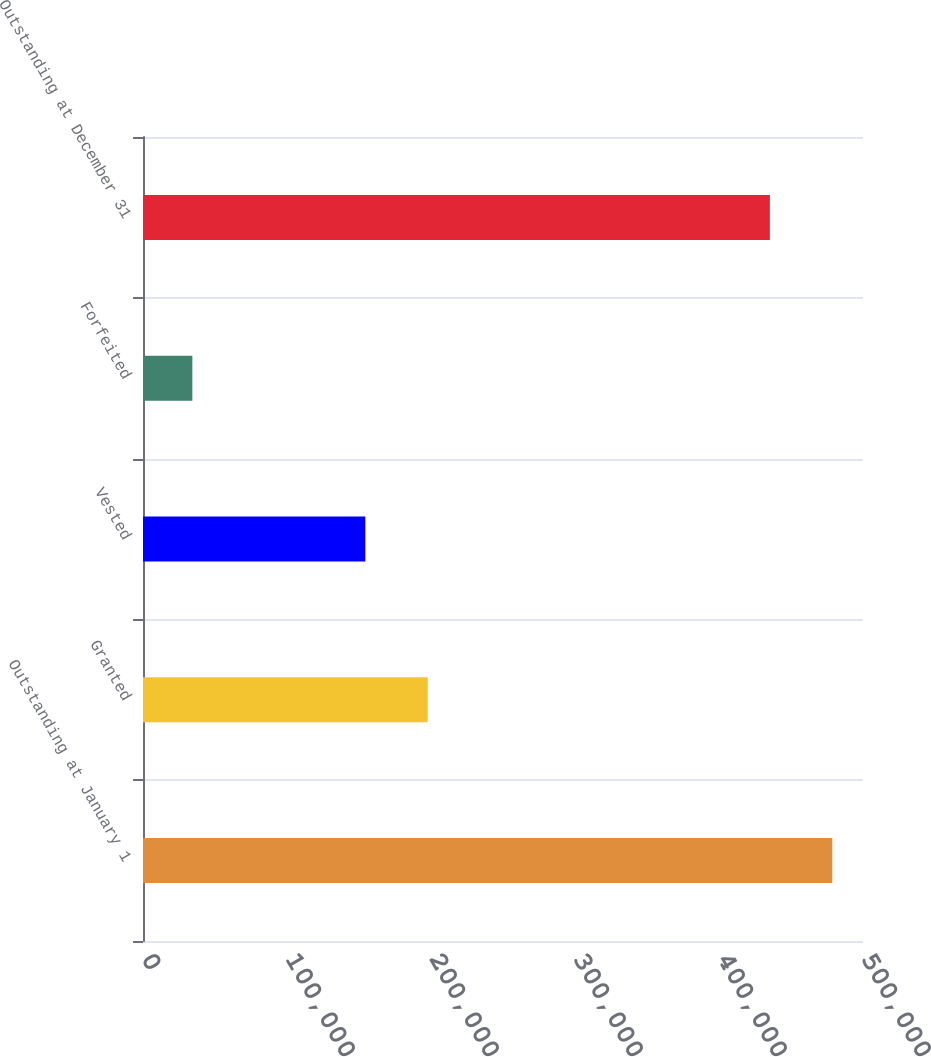Convert chart. <chart><loc_0><loc_0><loc_500><loc_500><bar_chart><fcel>Outstanding at January 1<fcel>Granted<fcel>Vested<fcel>Forfeited<fcel>Outstanding at December 31<nl><fcel>478682<fcel>197733<fcel>154387<fcel>34284<fcel>435336<nl></chart> 